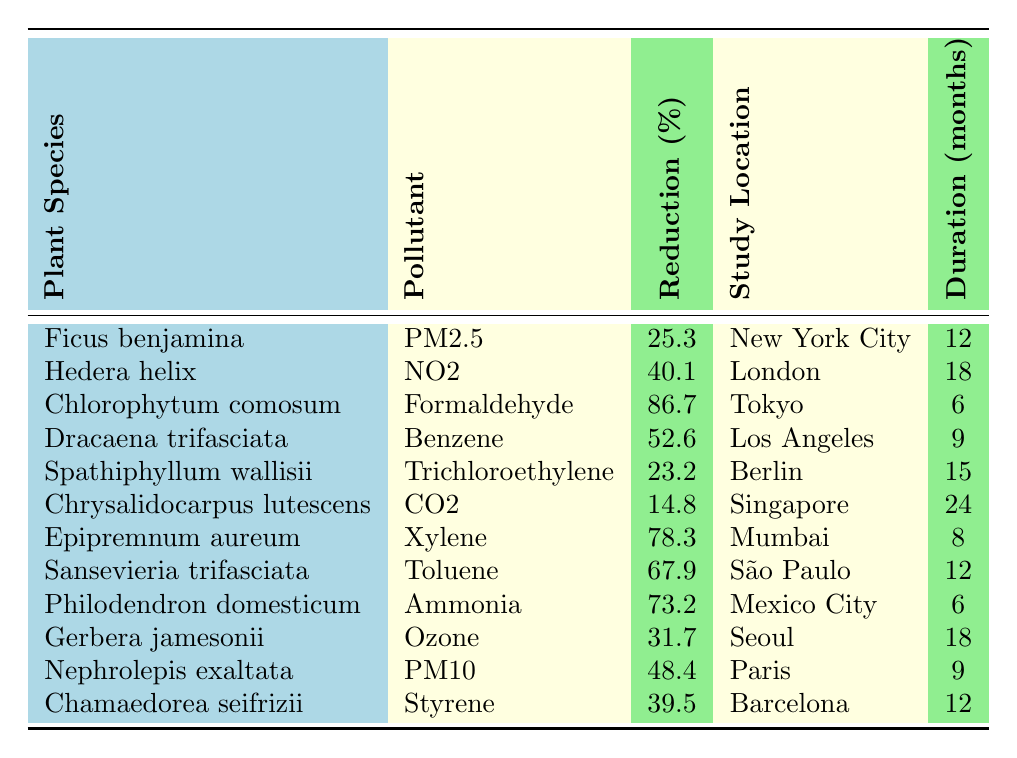What is the plant species that achieved the highest reduction in Formaldehyde? The table shows that Chlorophytum comosum achieved a reduction of 86.7% in Formaldehyde, which is the highest compared to other species and pollutants listed.
Answer: Chlorophytum comosum Which city had a study duration of 24 months? According to the table, the only plant listed with a study duration of 24 months is Chrysalidocarpus lutescens in Singapore.
Answer: Singapore What is the average reduction percentage of pollutants from the listed plants? To find the average, we sum the reduction percentages: (25.3 + 40.1 + 86.7 + 52.6 + 23.2 + 14.8 + 78.3 + 67.9 + 73.2 + 31.7 + 48.4 + 39.5) =  507.6. There are 12 species, so the average is 507.6 / 12 = 42.3.
Answer: 42.3 Is there any plant species that reduced CO2 levels? Yes, the table shows that Chrysalidocarpus lutescens reduced CO2 levels by 14.8%.
Answer: Yes Which plant species reduced Benzene levels and in what city was the study conducted? The plant species that reduced Benzene levels is Dracaena trifasciata, and the study was conducted in Los Angeles.
Answer: Dracaena trifasciata, Los Angeles What is the total percentage reduction from plants studied for PM2.5 and PM10? The reduction for PM2.5 from Ficus benjamina is 25.3% and for PM10 from Nephrolepis exaltata is 48.4%. Adding these gives 25.3 + 48.4 = 73.7%.
Answer: 73.7% How many plant species studied reduced pollutants by over 50%? Reviewing the table, the species with over 50% reduction are Chlorophytum comosum (86.7%), Dracaena trifasciata (52.6%), Epipremnum aureum (78.3%), Sansevieria trifasciata (67.9%), and Philodendron domesticum (73.2%). That gives a total of 5 species.
Answer: 5 Which pollutant had the lowest reduction percentage according to the data? The table indicates that the pollutant with the lowest reduction percentage is CO2, reduced by 14.8% by Chrysalidocarpus lutescens.
Answer: CO2 Did any plant species achieve more than 70% reduction across different pollutants? Yes, both Chlorophytum comosum (86.7% Formaldehyde) and Epipremnum aureum (78.3% Xylene) achieved more than 70% reduction.
Answer: Yes What is the difference in reduction percentage between the highest and lowest values from the table? Chlorophytum comosum had the highest reduction at 86.7%, and Chrysalidocarpus lutescens had the lowest at 14.8%. The difference is 86.7 - 14.8 = 71.9%.
Answer: 71.9% 